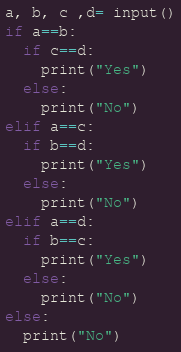Convert code to text. <code><loc_0><loc_0><loc_500><loc_500><_Python_>a, b, c ,d= input()
if a==b:
  if c==d:
    print("Yes")
  else:
    print("No")
elif a==c:
  if b==d:
    print("Yes")
  else:
    print("No")
elif a==d:
  if b==c:
    print("Yes")
  else:
    print("No")
else:
  print("No")

</code> 